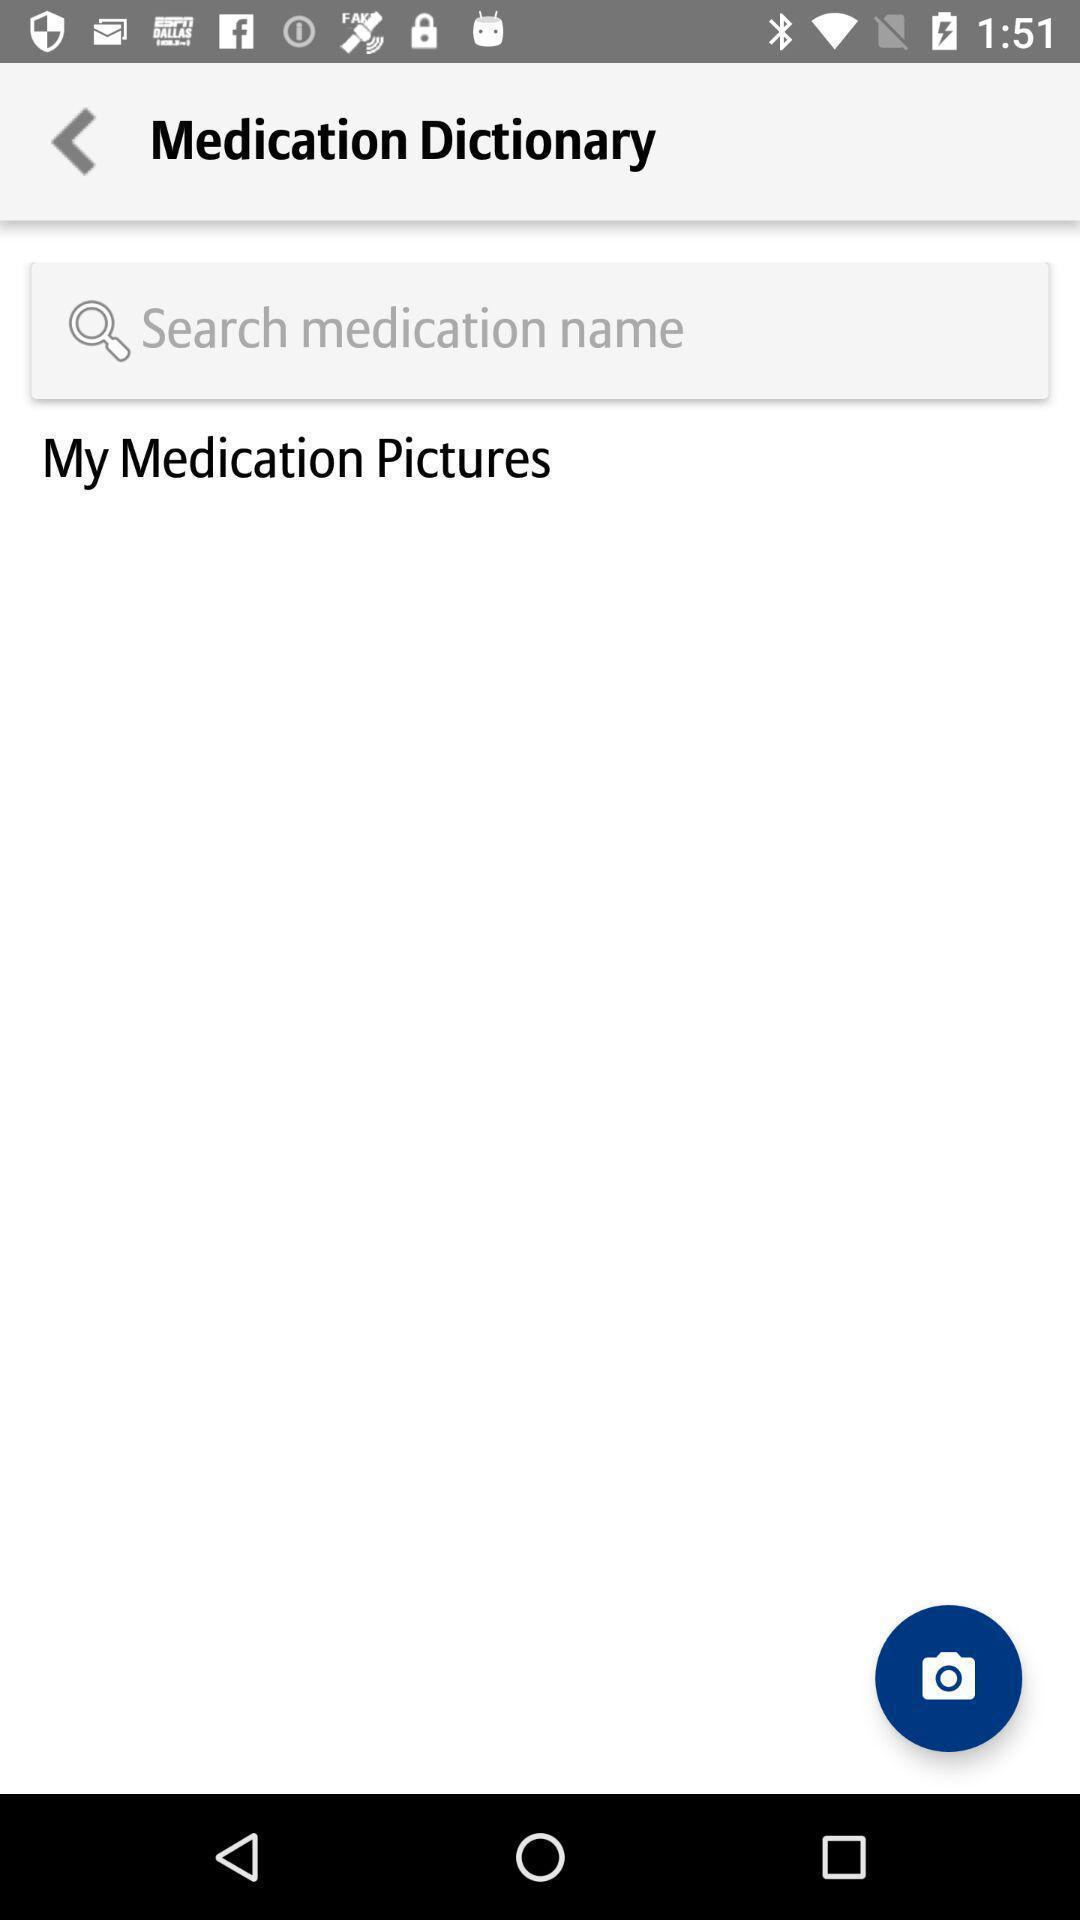Explain the elements present in this screenshot. Search bar to search name of the medication in app. 